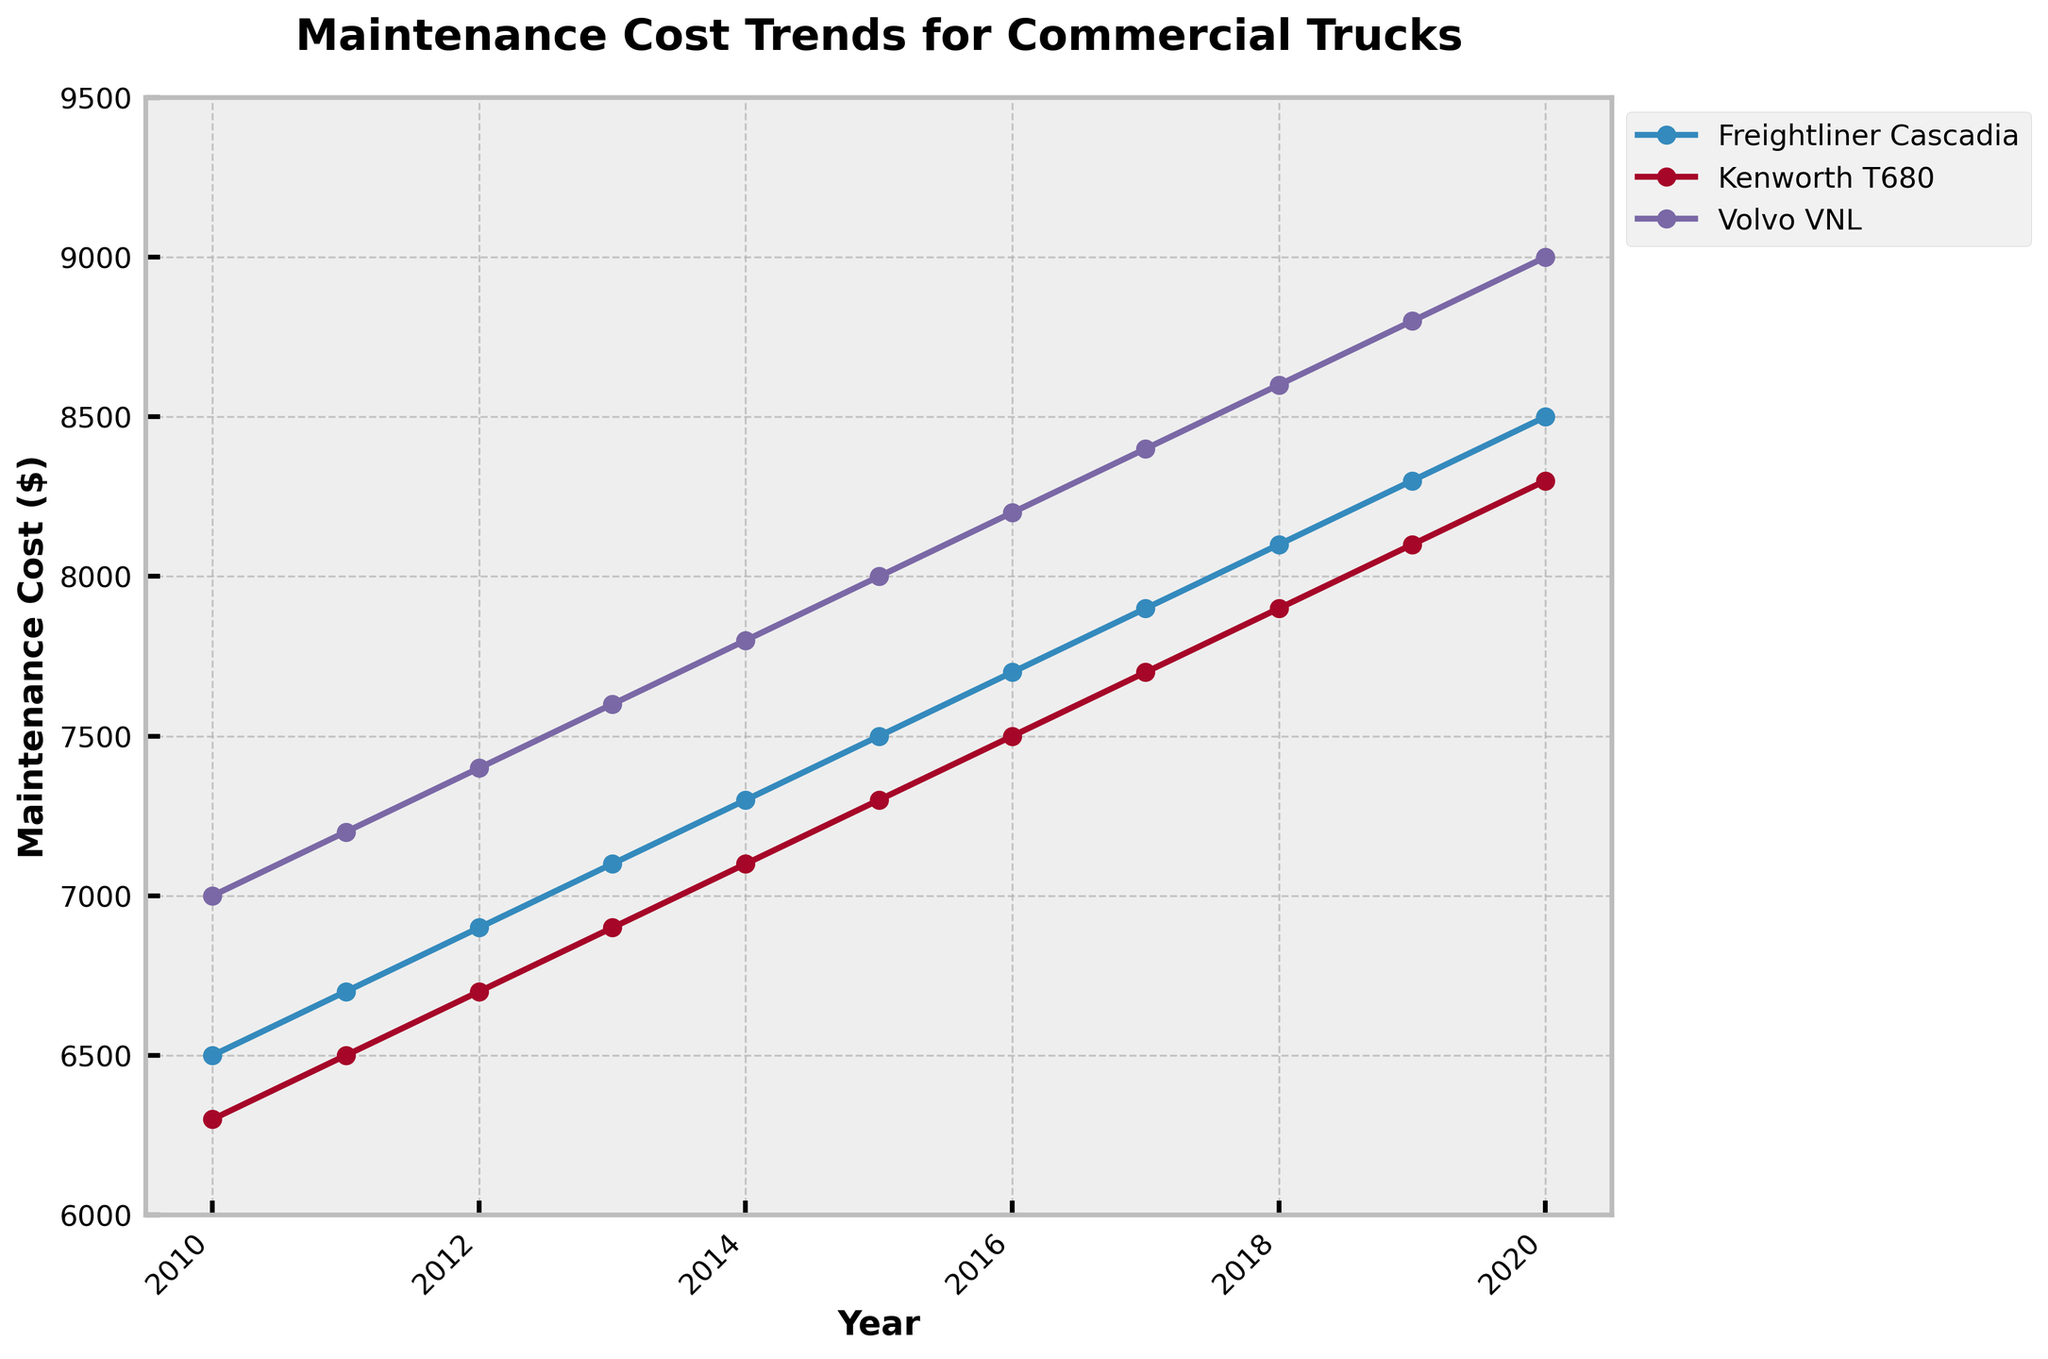what's the title of the plot? The title of the plot is written at the top and reads "Maintenance Cost Trends for Commercial Trucks".
Answer: Maintenance Cost Trends for Commercial Trucks what is the maximum value on the y-axis? The maximum value on the y-axis can be identified by looking at the highest number labeled on it, which is 9500.
Answer: 9500 how many different truck models are displayed in the plot? The plot legend shows the different truck models; there are three: Freightliner Cascadia, Kenworth T680, and Volvo VNL.
Answer: 3 which truck model had the highest maintenance cost in 2020? To find out the highest maintenance cost in 2020, look at the rightmost end of each line and compare the values: Volvo VNL tops at 9000.
Answer: Volvo VNL what's the general trend of maintenance costs over the years for Freightliner Cascadia? By observing the line associated with Freightliner Cascadia from left to right, we see a continuous upward trend indicating increasing costs.
Answer: Increasing which year had the lowest maintenance cost for Kenworth T680 and what was the cost? For Kenworth T680, look at the entire line and note the lowest point, which is in 2010 at $6300.
Answer: 2010, $6300 by how much did the maintenance cost for Volvo VNL increase from 2010 to 2020? Check the start (2010: 7000) and end (2020: 9000) points for Volvo VNL and subtract the values to find the difference: 9000 - 7000 = 2000.
Answer: $2000 compare the maintenance cost of Freightliner Cascadia and Kenworth T680 in 2015, which one is higher? Look at the values for both truck models in 2015: Freightliner Cascadia is at $7500 and Kenworth T680 is at $7300. Freightliner Cascadia is higher.
Answer: Freightliner Cascadia what's the average maintenance cost of Volvo VNL over the given years? Find the maintenance costs for Volvo VNL from 2010 to 2020 and calculate the average: (7000 + 7200 + 7400 + 7600 + 7800 + 8000 + 8200 + 8400 + 8600 + 8800 + 9000) / 11 = 8000.
Answer: $8000 